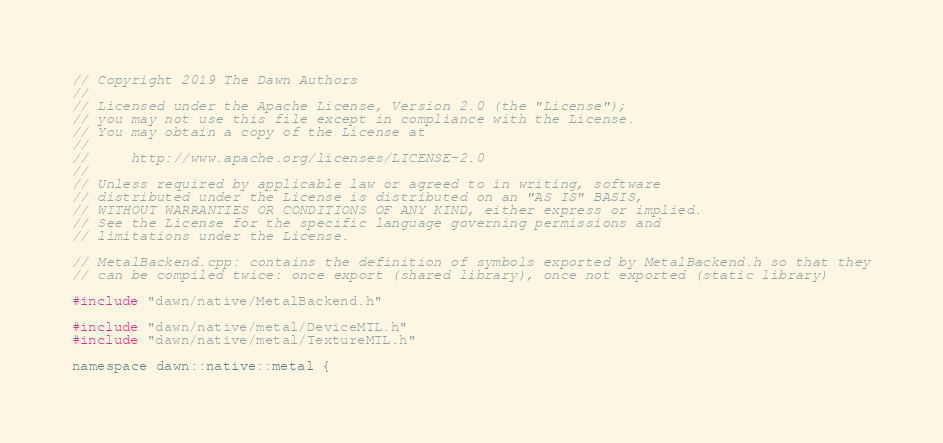<code> <loc_0><loc_0><loc_500><loc_500><_ObjectiveC_>// Copyright 2019 The Dawn Authors
//
// Licensed under the Apache License, Version 2.0 (the "License");
// you may not use this file except in compliance with the License.
// You may obtain a copy of the License at
//
//     http://www.apache.org/licenses/LICENSE-2.0
//
// Unless required by applicable law or agreed to in writing, software
// distributed under the License is distributed on an "AS IS" BASIS,
// WITHOUT WARRANTIES OR CONDITIONS OF ANY KIND, either express or implied.
// See the License for the specific language governing permissions and
// limitations under the License.

// MetalBackend.cpp: contains the definition of symbols exported by MetalBackend.h so that they
// can be compiled twice: once export (shared library), once not exported (static library)

#include "dawn/native/MetalBackend.h"

#include "dawn/native/metal/DeviceMTL.h"
#include "dawn/native/metal/TextureMTL.h"

namespace dawn::native::metal {
</code> 